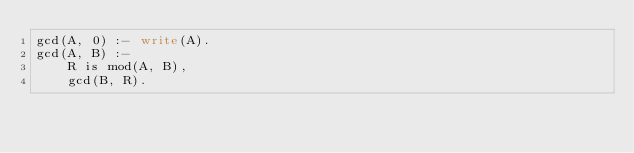<code> <loc_0><loc_0><loc_500><loc_500><_Perl_>gcd(A, 0) :- write(A).
gcd(A, B) :- 
    R is mod(A, B),
    gcd(B, R).
    



</code> 